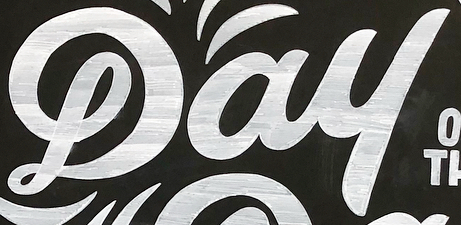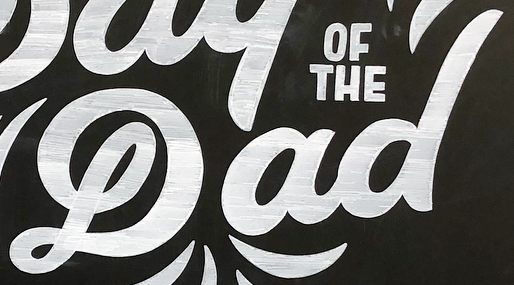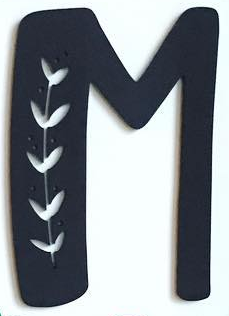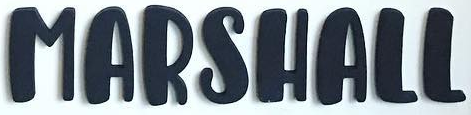What text appears in these images from left to right, separated by a semicolon? Dau; Dad; M; MARSHALL 